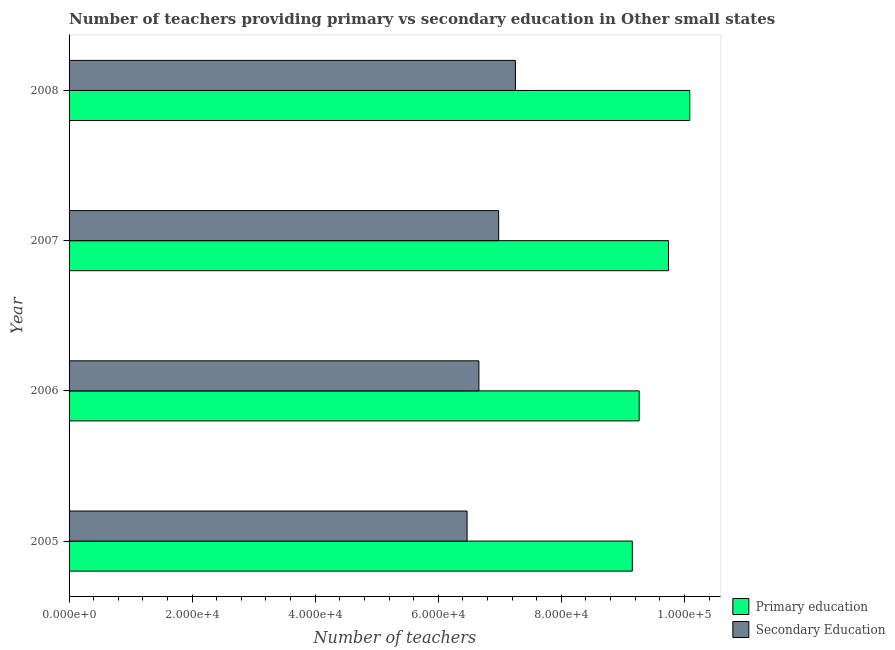How many different coloured bars are there?
Give a very brief answer. 2. How many groups of bars are there?
Your answer should be very brief. 4. How many bars are there on the 1st tick from the top?
Keep it short and to the point. 2. How many bars are there on the 3rd tick from the bottom?
Ensure brevity in your answer.  2. In how many cases, is the number of bars for a given year not equal to the number of legend labels?
Your answer should be very brief. 0. What is the number of secondary teachers in 2008?
Provide a short and direct response. 7.25e+04. Across all years, what is the maximum number of primary teachers?
Provide a short and direct response. 1.01e+05. Across all years, what is the minimum number of secondary teachers?
Offer a terse response. 6.47e+04. In which year was the number of secondary teachers maximum?
Your answer should be very brief. 2008. In which year was the number of secondary teachers minimum?
Provide a short and direct response. 2005. What is the total number of secondary teachers in the graph?
Give a very brief answer. 2.74e+05. What is the difference between the number of primary teachers in 2006 and that in 2007?
Your answer should be very brief. -4766.31. What is the difference between the number of primary teachers in 2008 and the number of secondary teachers in 2006?
Your response must be concise. 3.43e+04. What is the average number of primary teachers per year?
Provide a short and direct response. 9.56e+04. In the year 2005, what is the difference between the number of primary teachers and number of secondary teachers?
Ensure brevity in your answer.  2.69e+04. In how many years, is the number of primary teachers greater than 84000 ?
Keep it short and to the point. 4. What is the ratio of the number of primary teachers in 2005 to that in 2006?
Provide a succinct answer. 0.99. Is the difference between the number of secondary teachers in 2005 and 2007 greater than the difference between the number of primary teachers in 2005 and 2007?
Make the answer very short. Yes. What is the difference between the highest and the second highest number of primary teachers?
Offer a very short reply. 3458.15. What is the difference between the highest and the lowest number of secondary teachers?
Ensure brevity in your answer.  7857.45. Is the sum of the number of primary teachers in 2005 and 2007 greater than the maximum number of secondary teachers across all years?
Keep it short and to the point. Yes. What does the 1st bar from the top in 2008 represents?
Give a very brief answer. Secondary Education. What does the 1st bar from the bottom in 2007 represents?
Give a very brief answer. Primary education. How many bars are there?
Offer a very short reply. 8. What is the difference between two consecutive major ticks on the X-axis?
Your answer should be very brief. 2.00e+04. What is the title of the graph?
Give a very brief answer. Number of teachers providing primary vs secondary education in Other small states. Does "Secondary education" appear as one of the legend labels in the graph?
Give a very brief answer. No. What is the label or title of the X-axis?
Ensure brevity in your answer.  Number of teachers. What is the Number of teachers in Primary education in 2005?
Your response must be concise. 9.15e+04. What is the Number of teachers of Secondary Education in 2005?
Provide a succinct answer. 6.47e+04. What is the Number of teachers in Primary education in 2006?
Offer a terse response. 9.26e+04. What is the Number of teachers of Secondary Education in 2006?
Your response must be concise. 6.66e+04. What is the Number of teachers in Primary education in 2007?
Keep it short and to the point. 9.74e+04. What is the Number of teachers of Secondary Education in 2007?
Keep it short and to the point. 6.98e+04. What is the Number of teachers in Primary education in 2008?
Your answer should be compact. 1.01e+05. What is the Number of teachers in Secondary Education in 2008?
Offer a terse response. 7.25e+04. Across all years, what is the maximum Number of teachers of Primary education?
Your answer should be compact. 1.01e+05. Across all years, what is the maximum Number of teachers in Secondary Education?
Keep it short and to the point. 7.25e+04. Across all years, what is the minimum Number of teachers in Primary education?
Keep it short and to the point. 9.15e+04. Across all years, what is the minimum Number of teachers in Secondary Education?
Offer a very short reply. 6.47e+04. What is the total Number of teachers in Primary education in the graph?
Provide a short and direct response. 3.82e+05. What is the total Number of teachers of Secondary Education in the graph?
Keep it short and to the point. 2.74e+05. What is the difference between the Number of teachers in Primary education in 2005 and that in 2006?
Make the answer very short. -1112.46. What is the difference between the Number of teachers of Secondary Education in 2005 and that in 2006?
Provide a succinct answer. -1921.81. What is the difference between the Number of teachers in Primary education in 2005 and that in 2007?
Offer a terse response. -5878.77. What is the difference between the Number of teachers of Secondary Education in 2005 and that in 2007?
Your answer should be very brief. -5129.94. What is the difference between the Number of teachers in Primary education in 2005 and that in 2008?
Keep it short and to the point. -9336.92. What is the difference between the Number of teachers in Secondary Education in 2005 and that in 2008?
Your response must be concise. -7857.45. What is the difference between the Number of teachers in Primary education in 2006 and that in 2007?
Offer a very short reply. -4766.31. What is the difference between the Number of teachers in Secondary Education in 2006 and that in 2007?
Provide a succinct answer. -3208.12. What is the difference between the Number of teachers in Primary education in 2006 and that in 2008?
Provide a short and direct response. -8224.46. What is the difference between the Number of teachers in Secondary Education in 2006 and that in 2008?
Keep it short and to the point. -5935.64. What is the difference between the Number of teachers in Primary education in 2007 and that in 2008?
Provide a short and direct response. -3458.15. What is the difference between the Number of teachers in Secondary Education in 2007 and that in 2008?
Offer a terse response. -2727.52. What is the difference between the Number of teachers of Primary education in 2005 and the Number of teachers of Secondary Education in 2006?
Give a very brief answer. 2.49e+04. What is the difference between the Number of teachers of Primary education in 2005 and the Number of teachers of Secondary Education in 2007?
Ensure brevity in your answer.  2.17e+04. What is the difference between the Number of teachers in Primary education in 2005 and the Number of teachers in Secondary Education in 2008?
Offer a terse response. 1.90e+04. What is the difference between the Number of teachers in Primary education in 2006 and the Number of teachers in Secondary Education in 2007?
Your answer should be very brief. 2.28e+04. What is the difference between the Number of teachers of Primary education in 2006 and the Number of teachers of Secondary Education in 2008?
Your response must be concise. 2.01e+04. What is the difference between the Number of teachers in Primary education in 2007 and the Number of teachers in Secondary Education in 2008?
Provide a succinct answer. 2.49e+04. What is the average Number of teachers in Primary education per year?
Offer a terse response. 9.56e+04. What is the average Number of teachers in Secondary Education per year?
Your response must be concise. 6.84e+04. In the year 2005, what is the difference between the Number of teachers of Primary education and Number of teachers of Secondary Education?
Keep it short and to the point. 2.69e+04. In the year 2006, what is the difference between the Number of teachers of Primary education and Number of teachers of Secondary Education?
Your answer should be compact. 2.60e+04. In the year 2007, what is the difference between the Number of teachers in Primary education and Number of teachers in Secondary Education?
Offer a terse response. 2.76e+04. In the year 2008, what is the difference between the Number of teachers of Primary education and Number of teachers of Secondary Education?
Provide a short and direct response. 2.83e+04. What is the ratio of the Number of teachers of Primary education in 2005 to that in 2006?
Provide a short and direct response. 0.99. What is the ratio of the Number of teachers of Secondary Education in 2005 to that in 2006?
Your response must be concise. 0.97. What is the ratio of the Number of teachers of Primary education in 2005 to that in 2007?
Give a very brief answer. 0.94. What is the ratio of the Number of teachers in Secondary Education in 2005 to that in 2007?
Give a very brief answer. 0.93. What is the ratio of the Number of teachers in Primary education in 2005 to that in 2008?
Your answer should be compact. 0.91. What is the ratio of the Number of teachers in Secondary Education in 2005 to that in 2008?
Keep it short and to the point. 0.89. What is the ratio of the Number of teachers in Primary education in 2006 to that in 2007?
Offer a terse response. 0.95. What is the ratio of the Number of teachers in Secondary Education in 2006 to that in 2007?
Your response must be concise. 0.95. What is the ratio of the Number of teachers in Primary education in 2006 to that in 2008?
Your response must be concise. 0.92. What is the ratio of the Number of teachers in Secondary Education in 2006 to that in 2008?
Ensure brevity in your answer.  0.92. What is the ratio of the Number of teachers of Primary education in 2007 to that in 2008?
Your response must be concise. 0.97. What is the ratio of the Number of teachers of Secondary Education in 2007 to that in 2008?
Provide a succinct answer. 0.96. What is the difference between the highest and the second highest Number of teachers of Primary education?
Ensure brevity in your answer.  3458.15. What is the difference between the highest and the second highest Number of teachers in Secondary Education?
Provide a succinct answer. 2727.52. What is the difference between the highest and the lowest Number of teachers in Primary education?
Keep it short and to the point. 9336.92. What is the difference between the highest and the lowest Number of teachers in Secondary Education?
Make the answer very short. 7857.45. 